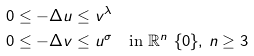Convert formula to latex. <formula><loc_0><loc_0><loc_500><loc_500>0 & \leq - \Delta u \leq v ^ { \lambda } \\ 0 & \leq - \Delta v \leq u ^ { \sigma } \text {\quad in } \mathbb { R } ^ { n } \ \{ 0 \} , \, n \geq 3</formula> 